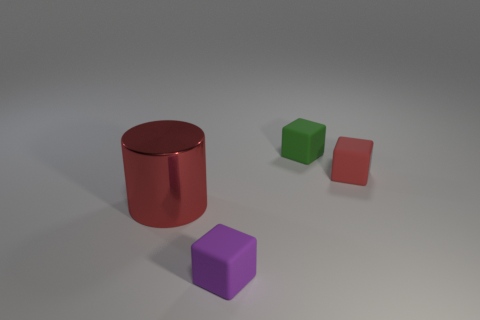Subtract all red matte cubes. How many cubes are left? 2 Subtract all cylinders. How many objects are left? 3 Add 4 green things. How many objects exist? 8 Subtract 3 cubes. How many cubes are left? 0 Add 4 big cyan shiny objects. How many big cyan shiny objects exist? 4 Subtract all green cubes. How many cubes are left? 2 Subtract 0 purple spheres. How many objects are left? 4 Subtract all brown cylinders. Subtract all red blocks. How many cylinders are left? 1 Subtract all yellow cylinders. How many purple cubes are left? 1 Subtract all red matte objects. Subtract all tiny cubes. How many objects are left? 0 